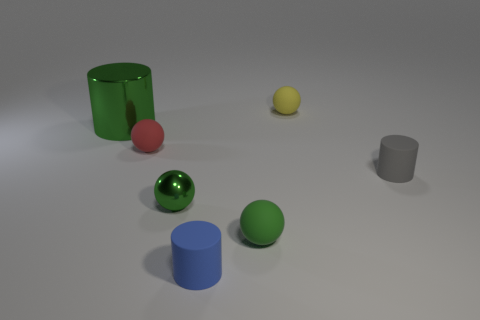Is there anything else that has the same color as the big shiny object?
Make the answer very short. Yes. Does the shiny thing right of the large thing have the same color as the cylinder left of the tiny blue cylinder?
Your answer should be compact. Yes. Are any tiny yellow rubber things visible?
Ensure brevity in your answer.  Yes. Is there a tiny yellow thing made of the same material as the gray cylinder?
Provide a succinct answer. Yes. What is the color of the large thing?
Your answer should be compact. Green. There is a shiny thing that is the same color as the big metal cylinder; what is its shape?
Offer a very short reply. Sphere. The shiny ball that is the same size as the gray matte object is what color?
Offer a terse response. Green. What number of metal things are things or small blue blocks?
Offer a terse response. 2. How many cylinders are both behind the small blue cylinder and right of the green cylinder?
Give a very brief answer. 1. Is there anything else that is the same shape as the small red object?
Ensure brevity in your answer.  Yes. 